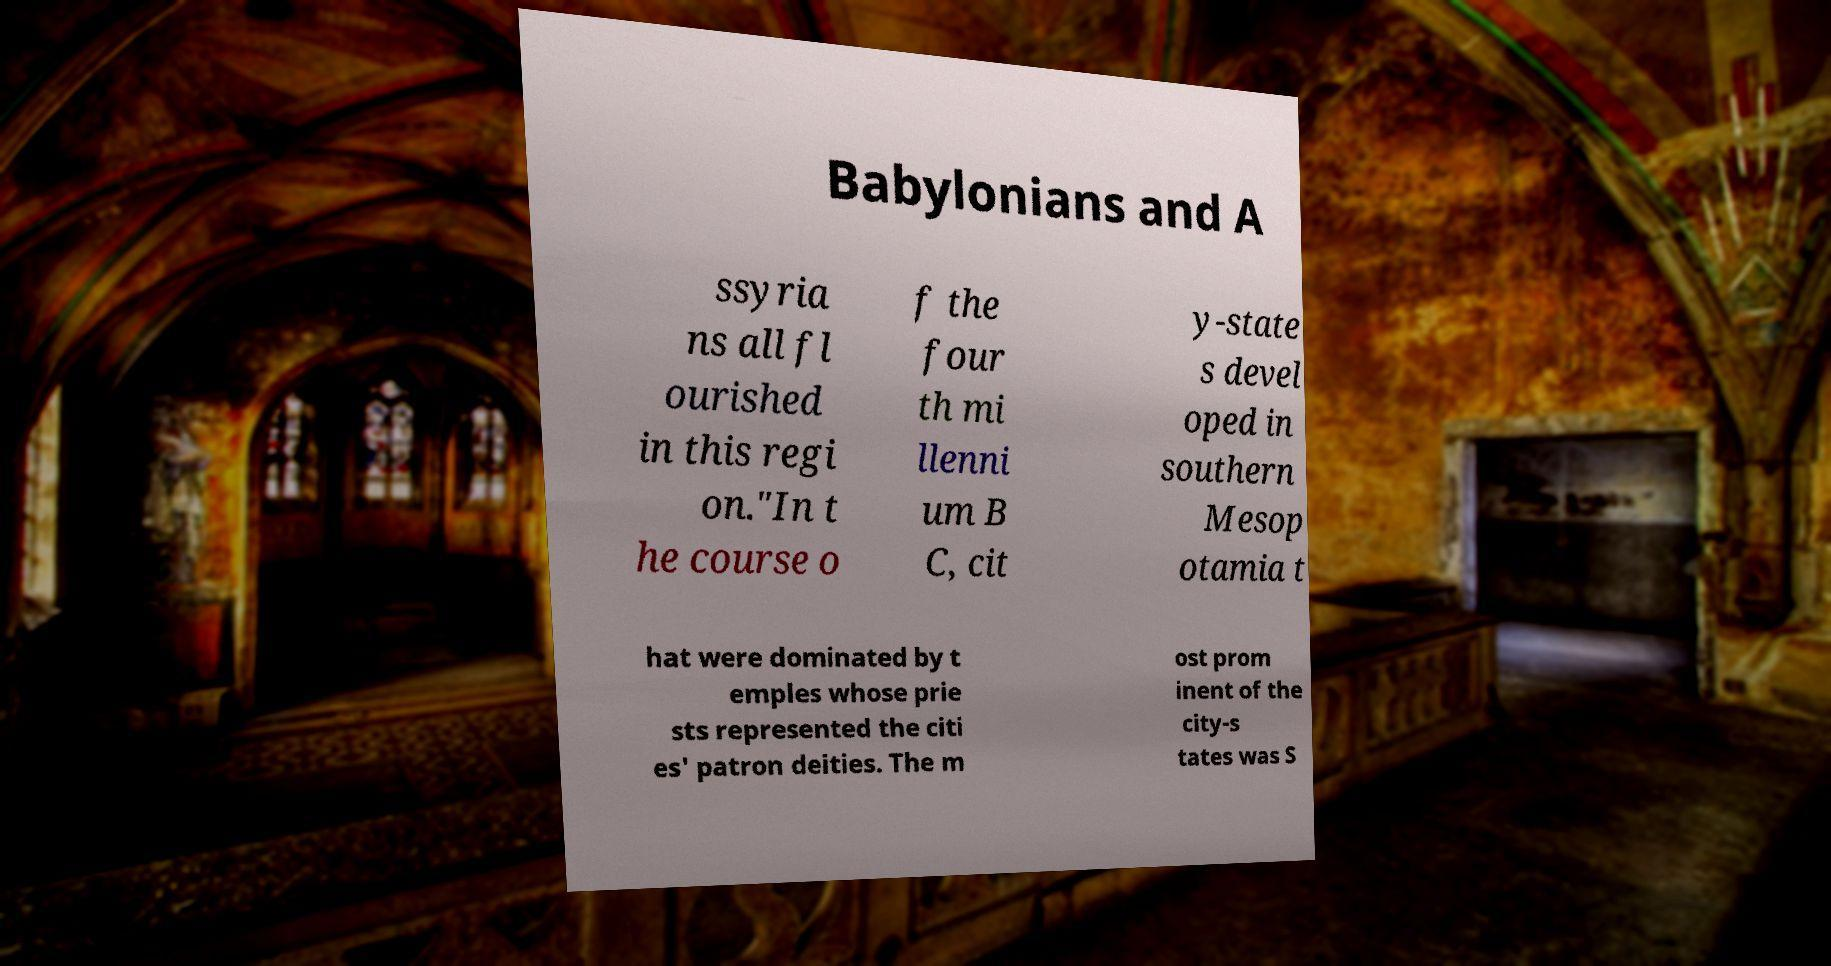What messages or text are displayed in this image? I need them in a readable, typed format. Babylonians and A ssyria ns all fl ourished in this regi on."In t he course o f the four th mi llenni um B C, cit y-state s devel oped in southern Mesop otamia t hat were dominated by t emples whose prie sts represented the citi es' patron deities. The m ost prom inent of the city-s tates was S 